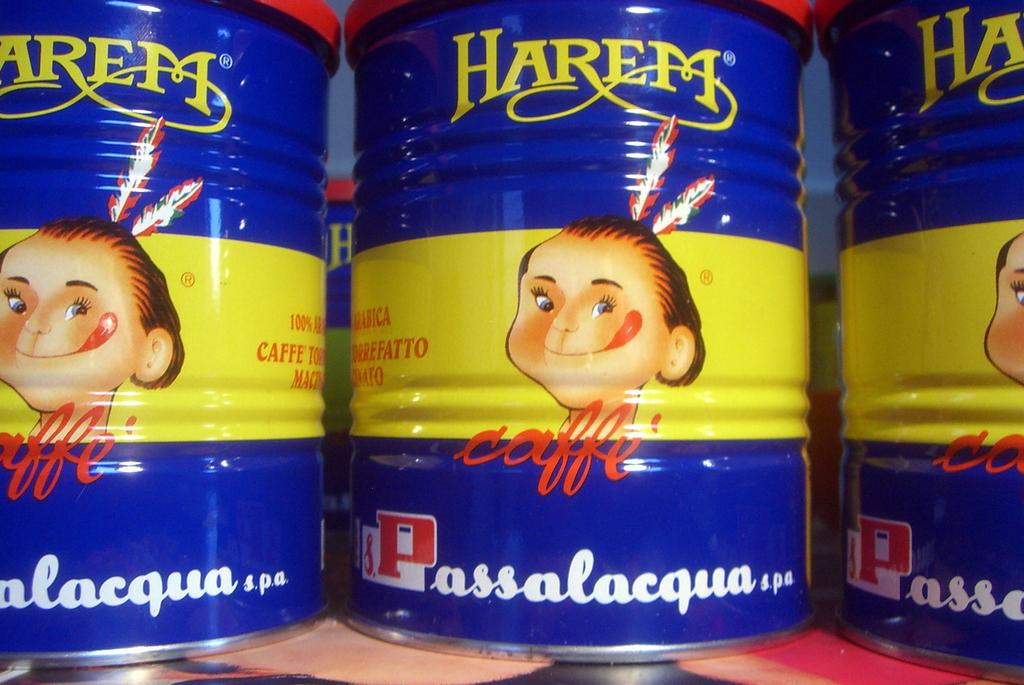Provide a one-sentence caption for the provided image. Three tins of Harem Coffee featuring a blue and yellow label with an American Indian on the front. 